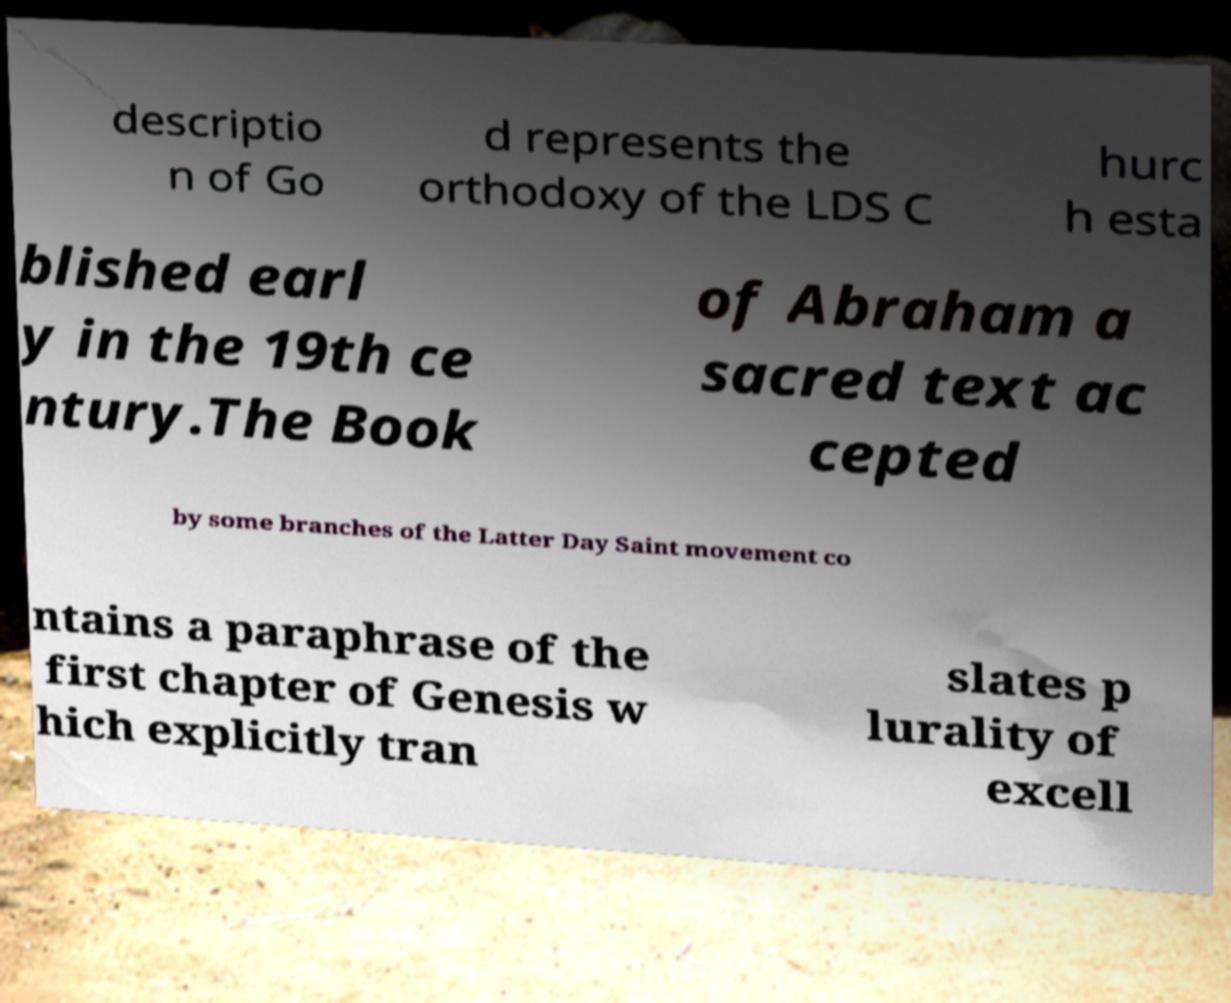Could you assist in decoding the text presented in this image and type it out clearly? descriptio n of Go d represents the orthodoxy of the LDS C hurc h esta blished earl y in the 19th ce ntury.The Book of Abraham a sacred text ac cepted by some branches of the Latter Day Saint movement co ntains a paraphrase of the first chapter of Genesis w hich explicitly tran slates p lurality of excell 